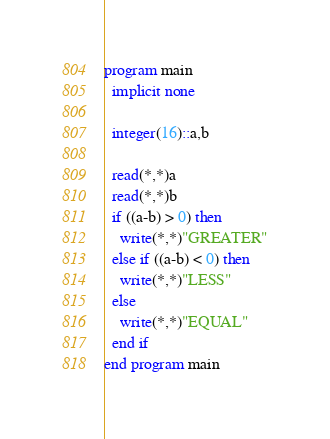<code> <loc_0><loc_0><loc_500><loc_500><_FORTRAN_>program main
  implicit none
  
  integer(16)::a,b
  
  read(*,*)a
  read(*,*)b
  if ((a-b) > 0) then
    write(*,*)"GREATER"
  else if ((a-b) < 0) then
    write(*,*)"LESS"
  else
    write(*,*)"EQUAL"
  end if
end program main</code> 